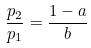<formula> <loc_0><loc_0><loc_500><loc_500>\frac { p _ { 2 } } { p _ { 1 } } = \frac { 1 - a } { b }</formula> 